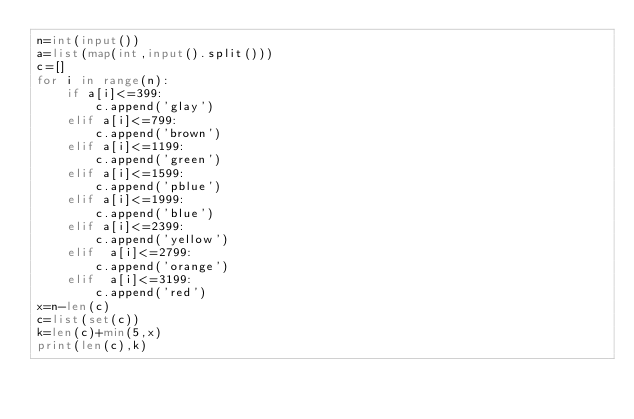Convert code to text. <code><loc_0><loc_0><loc_500><loc_500><_Python_>n=int(input())
a=list(map(int,input().split()))
c=[]
for i in range(n):
    if a[i]<=399:
        c.append('glay')
    elif a[i]<=799:
        c.append('brown') 
    elif a[i]<=1199:
        c.append('green')
    elif a[i]<=1599:
        c.append('pblue')
    elif a[i]<=1999:
        c.append('blue')
    elif a[i]<=2399:
        c.append('yellow')
    elif  a[i]<=2799:
        c.append('orange')
    elif  a[i]<=3199:
        c.append('red')
x=n-len(c)
c=list(set(c))
k=len(c)+min(5,x)
print(len(c),k)</code> 